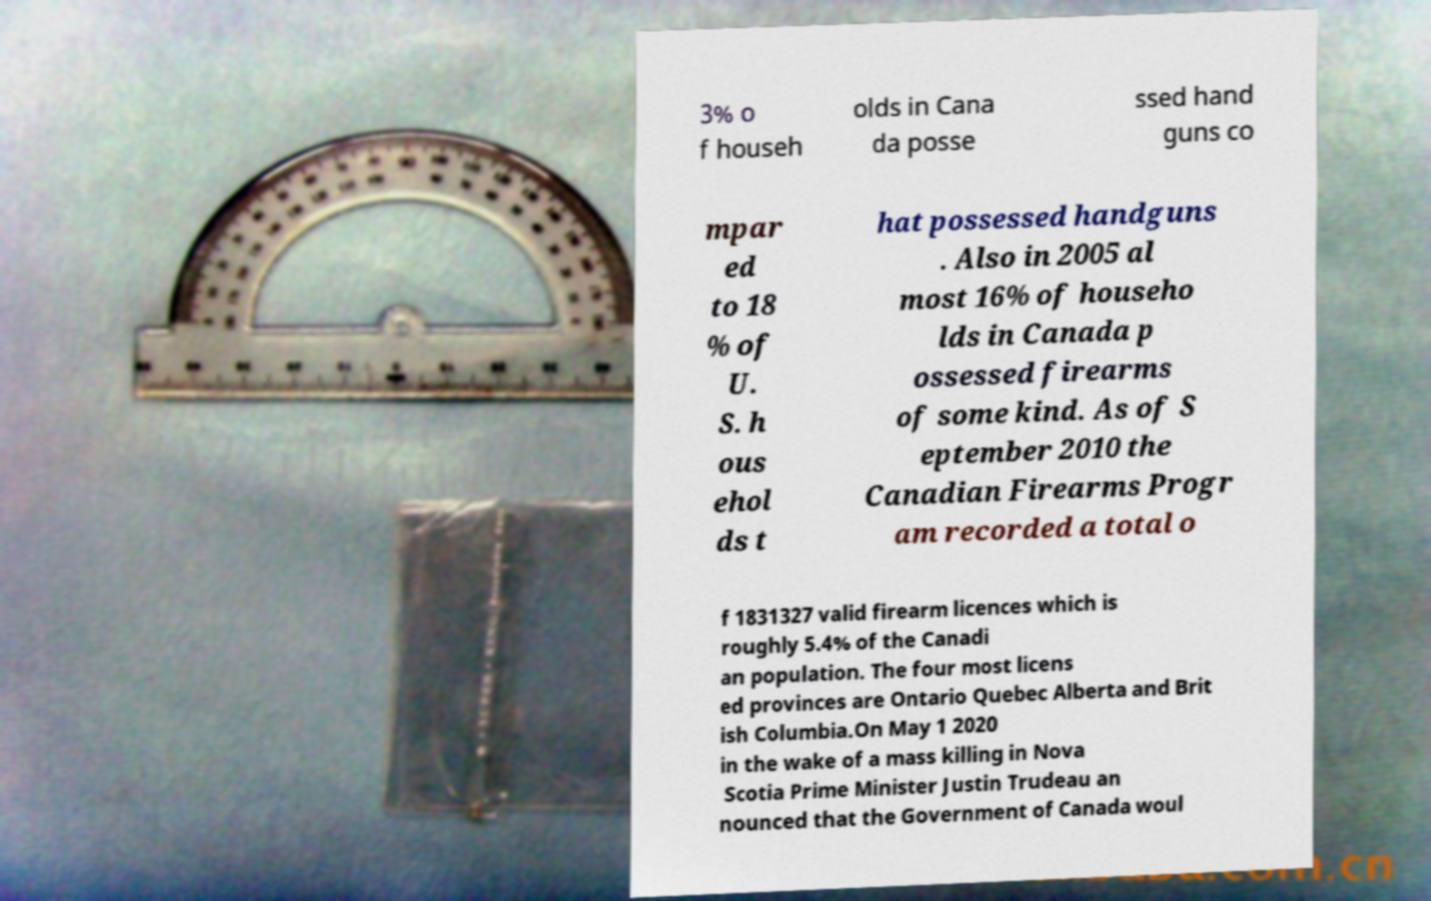Could you assist in decoding the text presented in this image and type it out clearly? 3% o f househ olds in Cana da posse ssed hand guns co mpar ed to 18 % of U. S. h ous ehol ds t hat possessed handguns . Also in 2005 al most 16% of househo lds in Canada p ossessed firearms of some kind. As of S eptember 2010 the Canadian Firearms Progr am recorded a total o f 1831327 valid firearm licences which is roughly 5.4% of the Canadi an population. The four most licens ed provinces are Ontario Quebec Alberta and Brit ish Columbia.On May 1 2020 in the wake of a mass killing in Nova Scotia Prime Minister Justin Trudeau an nounced that the Government of Canada woul 